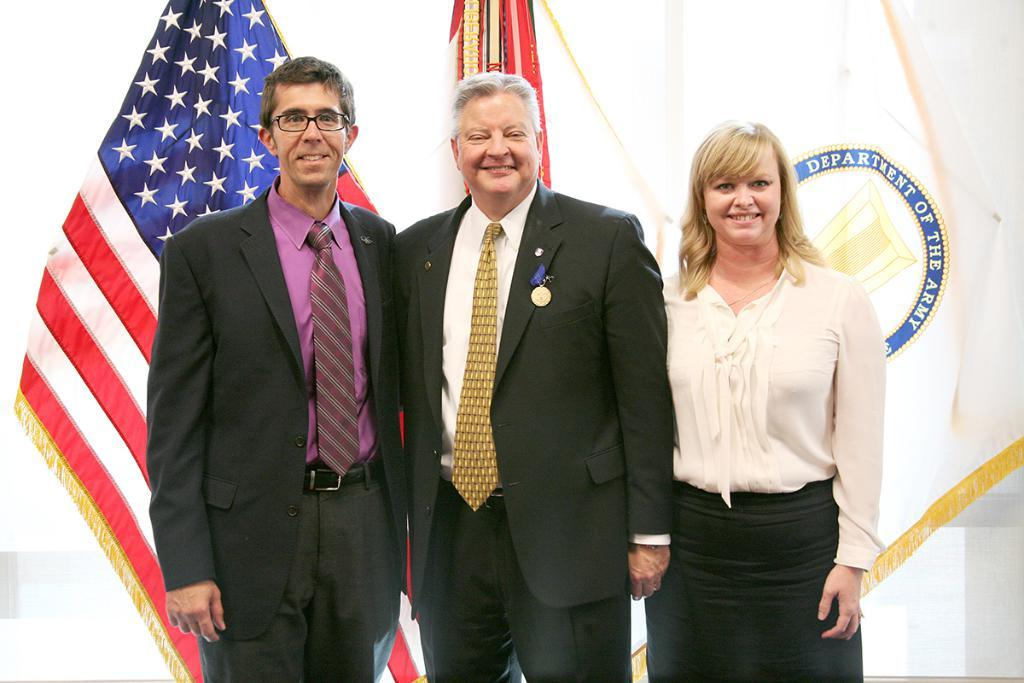How many people are present in the image? There are three people standing in the image. What can be seen behind the people? There are flags visible behind the people. Can you see a toad hopping near the people in the image? No, there is no toad present in the image. What type of footwear are the people wearing in the image? The provided facts do not mention any footwear, so we cannot determine what type of footwear the people are wearing. 